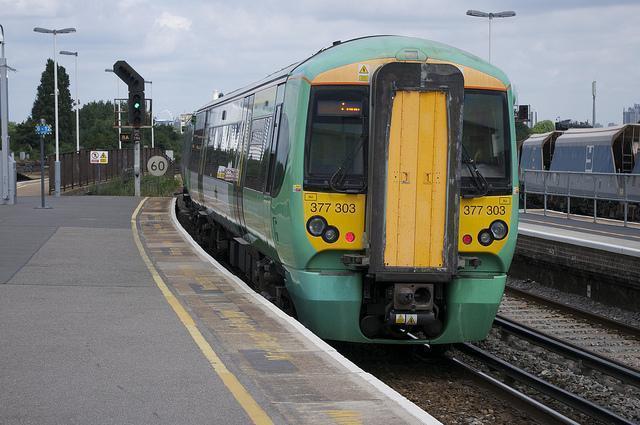How many trains are there?
Give a very brief answer. 2. 